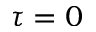<formula> <loc_0><loc_0><loc_500><loc_500>\tau = 0</formula> 